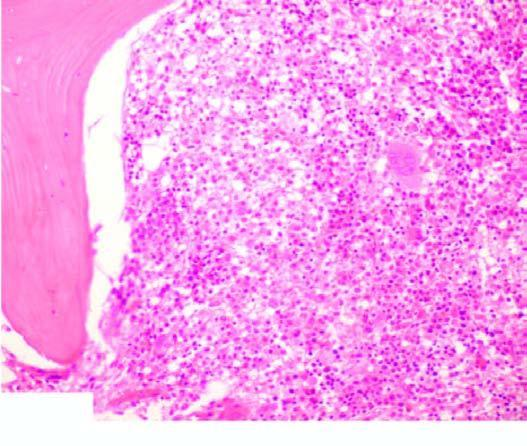what shows replacement of marrow spaces with abnormal mononuclear cells?
Answer the question using a single word or phrase. Trephine biopsy 